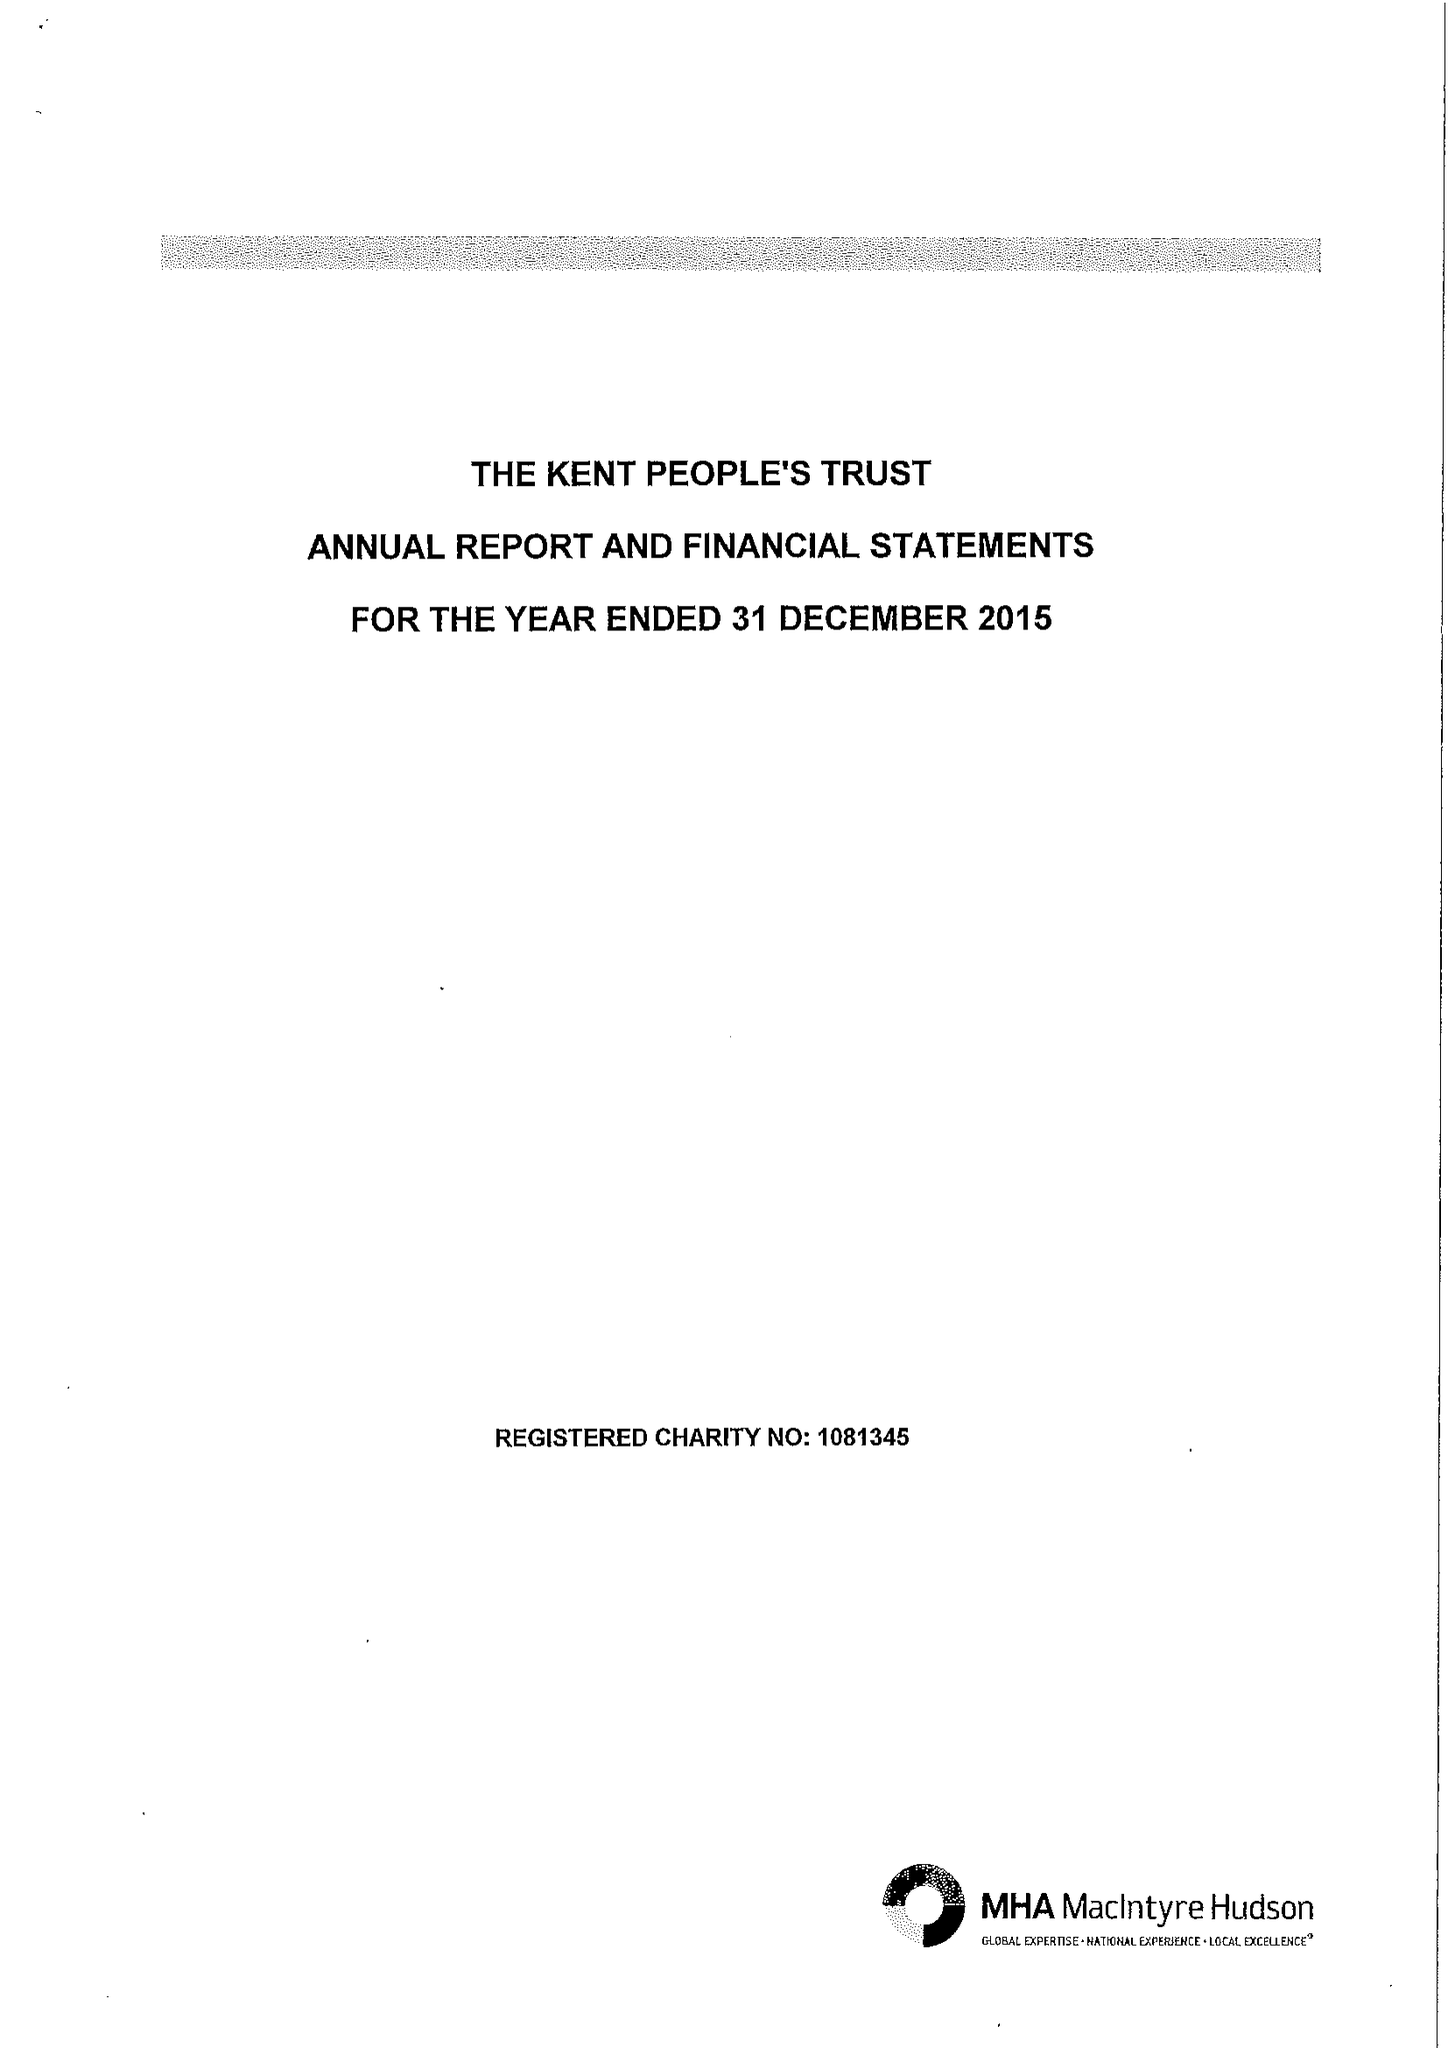What is the value for the income_annually_in_british_pounds?
Answer the question using a single word or phrase. 73259.00 